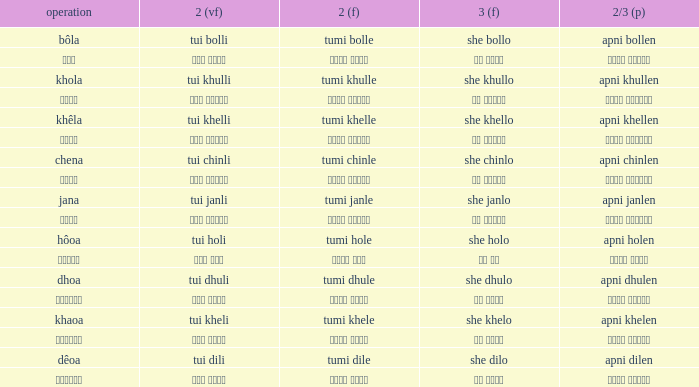What is the 2nd verb for chena? Tumi chinle. 